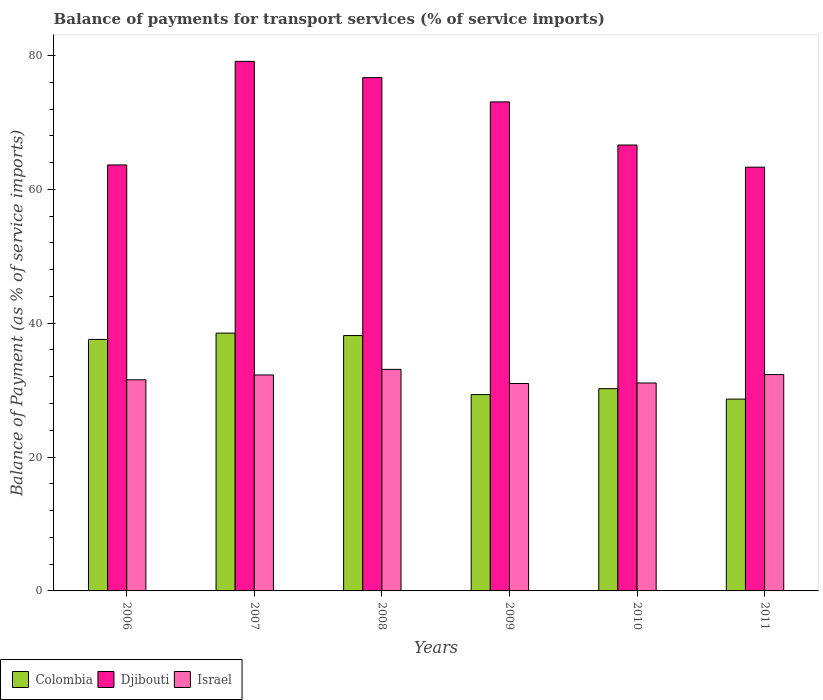How many different coloured bars are there?
Offer a terse response. 3. What is the balance of payments for transport services in Djibouti in 2006?
Offer a terse response. 63.64. Across all years, what is the maximum balance of payments for transport services in Djibouti?
Offer a terse response. 79.12. Across all years, what is the minimum balance of payments for transport services in Djibouti?
Ensure brevity in your answer.  63.31. In which year was the balance of payments for transport services in Djibouti minimum?
Offer a terse response. 2011. What is the total balance of payments for transport services in Colombia in the graph?
Offer a terse response. 202.45. What is the difference between the balance of payments for transport services in Colombia in 2009 and that in 2011?
Give a very brief answer. 0.67. What is the difference between the balance of payments for transport services in Colombia in 2008 and the balance of payments for transport services in Djibouti in 2006?
Ensure brevity in your answer.  -25.49. What is the average balance of payments for transport services in Israel per year?
Provide a succinct answer. 31.88. In the year 2010, what is the difference between the balance of payments for transport services in Colombia and balance of payments for transport services in Djibouti?
Make the answer very short. -36.4. In how many years, is the balance of payments for transport services in Djibouti greater than 24 %?
Make the answer very short. 6. What is the ratio of the balance of payments for transport services in Colombia in 2006 to that in 2010?
Offer a terse response. 1.24. Is the difference between the balance of payments for transport services in Colombia in 2009 and 2011 greater than the difference between the balance of payments for transport services in Djibouti in 2009 and 2011?
Make the answer very short. No. What is the difference between the highest and the second highest balance of payments for transport services in Israel?
Offer a terse response. 0.78. What is the difference between the highest and the lowest balance of payments for transport services in Djibouti?
Make the answer very short. 15.81. What does the 1st bar from the left in 2010 represents?
Make the answer very short. Colombia. Is it the case that in every year, the sum of the balance of payments for transport services in Djibouti and balance of payments for transport services in Colombia is greater than the balance of payments for transport services in Israel?
Offer a terse response. Yes. Are all the bars in the graph horizontal?
Offer a terse response. No. Where does the legend appear in the graph?
Ensure brevity in your answer.  Bottom left. How many legend labels are there?
Your response must be concise. 3. How are the legend labels stacked?
Ensure brevity in your answer.  Horizontal. What is the title of the graph?
Your answer should be compact. Balance of payments for transport services (% of service imports). Does "Arab World" appear as one of the legend labels in the graph?
Your answer should be very brief. No. What is the label or title of the X-axis?
Ensure brevity in your answer.  Years. What is the label or title of the Y-axis?
Keep it short and to the point. Balance of Payment (as % of service imports). What is the Balance of Payment (as % of service imports) in Colombia in 2006?
Ensure brevity in your answer.  37.57. What is the Balance of Payment (as % of service imports) of Djibouti in 2006?
Keep it short and to the point. 63.64. What is the Balance of Payment (as % of service imports) in Israel in 2006?
Make the answer very short. 31.55. What is the Balance of Payment (as % of service imports) in Colombia in 2007?
Ensure brevity in your answer.  38.52. What is the Balance of Payment (as % of service imports) of Djibouti in 2007?
Ensure brevity in your answer.  79.12. What is the Balance of Payment (as % of service imports) of Israel in 2007?
Offer a very short reply. 32.27. What is the Balance of Payment (as % of service imports) of Colombia in 2008?
Keep it short and to the point. 38.15. What is the Balance of Payment (as % of service imports) in Djibouti in 2008?
Keep it short and to the point. 76.69. What is the Balance of Payment (as % of service imports) in Israel in 2008?
Your answer should be compact. 33.1. What is the Balance of Payment (as % of service imports) in Colombia in 2009?
Your answer should be very brief. 29.33. What is the Balance of Payment (as % of service imports) in Djibouti in 2009?
Keep it short and to the point. 73.06. What is the Balance of Payment (as % of service imports) of Israel in 2009?
Ensure brevity in your answer.  30.99. What is the Balance of Payment (as % of service imports) in Colombia in 2010?
Keep it short and to the point. 30.22. What is the Balance of Payment (as % of service imports) in Djibouti in 2010?
Offer a very short reply. 66.62. What is the Balance of Payment (as % of service imports) in Israel in 2010?
Your response must be concise. 31.07. What is the Balance of Payment (as % of service imports) of Colombia in 2011?
Your answer should be compact. 28.66. What is the Balance of Payment (as % of service imports) in Djibouti in 2011?
Offer a very short reply. 63.31. What is the Balance of Payment (as % of service imports) in Israel in 2011?
Offer a terse response. 32.32. Across all years, what is the maximum Balance of Payment (as % of service imports) of Colombia?
Ensure brevity in your answer.  38.52. Across all years, what is the maximum Balance of Payment (as % of service imports) in Djibouti?
Offer a very short reply. 79.12. Across all years, what is the maximum Balance of Payment (as % of service imports) in Israel?
Give a very brief answer. 33.1. Across all years, what is the minimum Balance of Payment (as % of service imports) of Colombia?
Offer a terse response. 28.66. Across all years, what is the minimum Balance of Payment (as % of service imports) in Djibouti?
Your answer should be very brief. 63.31. Across all years, what is the minimum Balance of Payment (as % of service imports) of Israel?
Offer a terse response. 30.99. What is the total Balance of Payment (as % of service imports) of Colombia in the graph?
Offer a very short reply. 202.45. What is the total Balance of Payment (as % of service imports) of Djibouti in the graph?
Offer a very short reply. 422.45. What is the total Balance of Payment (as % of service imports) of Israel in the graph?
Your answer should be compact. 191.29. What is the difference between the Balance of Payment (as % of service imports) of Colombia in 2006 and that in 2007?
Your answer should be compact. -0.95. What is the difference between the Balance of Payment (as % of service imports) of Djibouti in 2006 and that in 2007?
Your response must be concise. -15.48. What is the difference between the Balance of Payment (as % of service imports) in Israel in 2006 and that in 2007?
Ensure brevity in your answer.  -0.72. What is the difference between the Balance of Payment (as % of service imports) in Colombia in 2006 and that in 2008?
Provide a succinct answer. -0.58. What is the difference between the Balance of Payment (as % of service imports) in Djibouti in 2006 and that in 2008?
Offer a very short reply. -13.05. What is the difference between the Balance of Payment (as % of service imports) in Israel in 2006 and that in 2008?
Provide a succinct answer. -1.56. What is the difference between the Balance of Payment (as % of service imports) of Colombia in 2006 and that in 2009?
Offer a very short reply. 8.25. What is the difference between the Balance of Payment (as % of service imports) of Djibouti in 2006 and that in 2009?
Keep it short and to the point. -9.42. What is the difference between the Balance of Payment (as % of service imports) of Israel in 2006 and that in 2009?
Offer a terse response. 0.55. What is the difference between the Balance of Payment (as % of service imports) in Colombia in 2006 and that in 2010?
Make the answer very short. 7.36. What is the difference between the Balance of Payment (as % of service imports) of Djibouti in 2006 and that in 2010?
Provide a succinct answer. -2.98. What is the difference between the Balance of Payment (as % of service imports) of Israel in 2006 and that in 2010?
Your response must be concise. 0.48. What is the difference between the Balance of Payment (as % of service imports) in Colombia in 2006 and that in 2011?
Keep it short and to the point. 8.92. What is the difference between the Balance of Payment (as % of service imports) in Djibouti in 2006 and that in 2011?
Your answer should be compact. 0.33. What is the difference between the Balance of Payment (as % of service imports) in Israel in 2006 and that in 2011?
Your answer should be compact. -0.78. What is the difference between the Balance of Payment (as % of service imports) of Colombia in 2007 and that in 2008?
Your answer should be compact. 0.37. What is the difference between the Balance of Payment (as % of service imports) of Djibouti in 2007 and that in 2008?
Your answer should be very brief. 2.43. What is the difference between the Balance of Payment (as % of service imports) of Colombia in 2007 and that in 2009?
Offer a very short reply. 9.19. What is the difference between the Balance of Payment (as % of service imports) of Djibouti in 2007 and that in 2009?
Your answer should be compact. 6.06. What is the difference between the Balance of Payment (as % of service imports) in Israel in 2007 and that in 2009?
Offer a terse response. 1.28. What is the difference between the Balance of Payment (as % of service imports) in Colombia in 2007 and that in 2010?
Ensure brevity in your answer.  8.3. What is the difference between the Balance of Payment (as % of service imports) in Djibouti in 2007 and that in 2010?
Ensure brevity in your answer.  12.5. What is the difference between the Balance of Payment (as % of service imports) in Israel in 2007 and that in 2010?
Provide a succinct answer. 1.2. What is the difference between the Balance of Payment (as % of service imports) of Colombia in 2007 and that in 2011?
Offer a very short reply. 9.86. What is the difference between the Balance of Payment (as % of service imports) in Djibouti in 2007 and that in 2011?
Provide a succinct answer. 15.81. What is the difference between the Balance of Payment (as % of service imports) of Israel in 2007 and that in 2011?
Your answer should be very brief. -0.05. What is the difference between the Balance of Payment (as % of service imports) in Colombia in 2008 and that in 2009?
Provide a short and direct response. 8.83. What is the difference between the Balance of Payment (as % of service imports) in Djibouti in 2008 and that in 2009?
Ensure brevity in your answer.  3.63. What is the difference between the Balance of Payment (as % of service imports) of Israel in 2008 and that in 2009?
Give a very brief answer. 2.11. What is the difference between the Balance of Payment (as % of service imports) of Colombia in 2008 and that in 2010?
Provide a succinct answer. 7.94. What is the difference between the Balance of Payment (as % of service imports) in Djibouti in 2008 and that in 2010?
Provide a succinct answer. 10.07. What is the difference between the Balance of Payment (as % of service imports) in Israel in 2008 and that in 2010?
Offer a terse response. 2.04. What is the difference between the Balance of Payment (as % of service imports) of Colombia in 2008 and that in 2011?
Your response must be concise. 9.5. What is the difference between the Balance of Payment (as % of service imports) of Djibouti in 2008 and that in 2011?
Ensure brevity in your answer.  13.38. What is the difference between the Balance of Payment (as % of service imports) in Israel in 2008 and that in 2011?
Give a very brief answer. 0.78. What is the difference between the Balance of Payment (as % of service imports) in Colombia in 2009 and that in 2010?
Your response must be concise. -0.89. What is the difference between the Balance of Payment (as % of service imports) in Djibouti in 2009 and that in 2010?
Ensure brevity in your answer.  6.44. What is the difference between the Balance of Payment (as % of service imports) in Israel in 2009 and that in 2010?
Your answer should be very brief. -0.08. What is the difference between the Balance of Payment (as % of service imports) of Colombia in 2009 and that in 2011?
Ensure brevity in your answer.  0.67. What is the difference between the Balance of Payment (as % of service imports) of Djibouti in 2009 and that in 2011?
Keep it short and to the point. 9.75. What is the difference between the Balance of Payment (as % of service imports) of Israel in 2009 and that in 2011?
Provide a short and direct response. -1.33. What is the difference between the Balance of Payment (as % of service imports) in Colombia in 2010 and that in 2011?
Give a very brief answer. 1.56. What is the difference between the Balance of Payment (as % of service imports) in Djibouti in 2010 and that in 2011?
Your answer should be very brief. 3.31. What is the difference between the Balance of Payment (as % of service imports) in Israel in 2010 and that in 2011?
Give a very brief answer. -1.25. What is the difference between the Balance of Payment (as % of service imports) of Colombia in 2006 and the Balance of Payment (as % of service imports) of Djibouti in 2007?
Your answer should be very brief. -41.55. What is the difference between the Balance of Payment (as % of service imports) in Colombia in 2006 and the Balance of Payment (as % of service imports) in Israel in 2007?
Offer a terse response. 5.31. What is the difference between the Balance of Payment (as % of service imports) of Djibouti in 2006 and the Balance of Payment (as % of service imports) of Israel in 2007?
Make the answer very short. 31.38. What is the difference between the Balance of Payment (as % of service imports) in Colombia in 2006 and the Balance of Payment (as % of service imports) in Djibouti in 2008?
Give a very brief answer. -39.12. What is the difference between the Balance of Payment (as % of service imports) in Colombia in 2006 and the Balance of Payment (as % of service imports) in Israel in 2008?
Your answer should be compact. 4.47. What is the difference between the Balance of Payment (as % of service imports) of Djibouti in 2006 and the Balance of Payment (as % of service imports) of Israel in 2008?
Your answer should be compact. 30.54. What is the difference between the Balance of Payment (as % of service imports) of Colombia in 2006 and the Balance of Payment (as % of service imports) of Djibouti in 2009?
Make the answer very short. -35.49. What is the difference between the Balance of Payment (as % of service imports) in Colombia in 2006 and the Balance of Payment (as % of service imports) in Israel in 2009?
Provide a short and direct response. 6.58. What is the difference between the Balance of Payment (as % of service imports) of Djibouti in 2006 and the Balance of Payment (as % of service imports) of Israel in 2009?
Offer a terse response. 32.65. What is the difference between the Balance of Payment (as % of service imports) of Colombia in 2006 and the Balance of Payment (as % of service imports) of Djibouti in 2010?
Ensure brevity in your answer.  -29.04. What is the difference between the Balance of Payment (as % of service imports) in Colombia in 2006 and the Balance of Payment (as % of service imports) in Israel in 2010?
Your answer should be compact. 6.51. What is the difference between the Balance of Payment (as % of service imports) in Djibouti in 2006 and the Balance of Payment (as % of service imports) in Israel in 2010?
Provide a short and direct response. 32.58. What is the difference between the Balance of Payment (as % of service imports) of Colombia in 2006 and the Balance of Payment (as % of service imports) of Djibouti in 2011?
Ensure brevity in your answer.  -25.74. What is the difference between the Balance of Payment (as % of service imports) of Colombia in 2006 and the Balance of Payment (as % of service imports) of Israel in 2011?
Offer a very short reply. 5.25. What is the difference between the Balance of Payment (as % of service imports) in Djibouti in 2006 and the Balance of Payment (as % of service imports) in Israel in 2011?
Make the answer very short. 31.32. What is the difference between the Balance of Payment (as % of service imports) in Colombia in 2007 and the Balance of Payment (as % of service imports) in Djibouti in 2008?
Give a very brief answer. -38.17. What is the difference between the Balance of Payment (as % of service imports) of Colombia in 2007 and the Balance of Payment (as % of service imports) of Israel in 2008?
Ensure brevity in your answer.  5.42. What is the difference between the Balance of Payment (as % of service imports) in Djibouti in 2007 and the Balance of Payment (as % of service imports) in Israel in 2008?
Offer a very short reply. 46.02. What is the difference between the Balance of Payment (as % of service imports) in Colombia in 2007 and the Balance of Payment (as % of service imports) in Djibouti in 2009?
Your response must be concise. -34.54. What is the difference between the Balance of Payment (as % of service imports) of Colombia in 2007 and the Balance of Payment (as % of service imports) of Israel in 2009?
Your response must be concise. 7.53. What is the difference between the Balance of Payment (as % of service imports) of Djibouti in 2007 and the Balance of Payment (as % of service imports) of Israel in 2009?
Provide a succinct answer. 48.13. What is the difference between the Balance of Payment (as % of service imports) of Colombia in 2007 and the Balance of Payment (as % of service imports) of Djibouti in 2010?
Keep it short and to the point. -28.1. What is the difference between the Balance of Payment (as % of service imports) in Colombia in 2007 and the Balance of Payment (as % of service imports) in Israel in 2010?
Provide a succinct answer. 7.45. What is the difference between the Balance of Payment (as % of service imports) of Djibouti in 2007 and the Balance of Payment (as % of service imports) of Israel in 2010?
Offer a terse response. 48.05. What is the difference between the Balance of Payment (as % of service imports) of Colombia in 2007 and the Balance of Payment (as % of service imports) of Djibouti in 2011?
Give a very brief answer. -24.79. What is the difference between the Balance of Payment (as % of service imports) in Colombia in 2007 and the Balance of Payment (as % of service imports) in Israel in 2011?
Provide a succinct answer. 6.2. What is the difference between the Balance of Payment (as % of service imports) in Djibouti in 2007 and the Balance of Payment (as % of service imports) in Israel in 2011?
Make the answer very short. 46.8. What is the difference between the Balance of Payment (as % of service imports) of Colombia in 2008 and the Balance of Payment (as % of service imports) of Djibouti in 2009?
Your answer should be compact. -34.91. What is the difference between the Balance of Payment (as % of service imports) of Colombia in 2008 and the Balance of Payment (as % of service imports) of Israel in 2009?
Ensure brevity in your answer.  7.16. What is the difference between the Balance of Payment (as % of service imports) in Djibouti in 2008 and the Balance of Payment (as % of service imports) in Israel in 2009?
Ensure brevity in your answer.  45.7. What is the difference between the Balance of Payment (as % of service imports) in Colombia in 2008 and the Balance of Payment (as % of service imports) in Djibouti in 2010?
Your answer should be very brief. -28.46. What is the difference between the Balance of Payment (as % of service imports) in Colombia in 2008 and the Balance of Payment (as % of service imports) in Israel in 2010?
Offer a very short reply. 7.09. What is the difference between the Balance of Payment (as % of service imports) in Djibouti in 2008 and the Balance of Payment (as % of service imports) in Israel in 2010?
Offer a very short reply. 45.63. What is the difference between the Balance of Payment (as % of service imports) in Colombia in 2008 and the Balance of Payment (as % of service imports) in Djibouti in 2011?
Provide a succinct answer. -25.16. What is the difference between the Balance of Payment (as % of service imports) in Colombia in 2008 and the Balance of Payment (as % of service imports) in Israel in 2011?
Give a very brief answer. 5.83. What is the difference between the Balance of Payment (as % of service imports) of Djibouti in 2008 and the Balance of Payment (as % of service imports) of Israel in 2011?
Keep it short and to the point. 44.37. What is the difference between the Balance of Payment (as % of service imports) of Colombia in 2009 and the Balance of Payment (as % of service imports) of Djibouti in 2010?
Keep it short and to the point. -37.29. What is the difference between the Balance of Payment (as % of service imports) in Colombia in 2009 and the Balance of Payment (as % of service imports) in Israel in 2010?
Make the answer very short. -1.74. What is the difference between the Balance of Payment (as % of service imports) in Djibouti in 2009 and the Balance of Payment (as % of service imports) in Israel in 2010?
Provide a short and direct response. 42. What is the difference between the Balance of Payment (as % of service imports) of Colombia in 2009 and the Balance of Payment (as % of service imports) of Djibouti in 2011?
Make the answer very short. -33.98. What is the difference between the Balance of Payment (as % of service imports) in Colombia in 2009 and the Balance of Payment (as % of service imports) in Israel in 2011?
Your answer should be very brief. -2.99. What is the difference between the Balance of Payment (as % of service imports) of Djibouti in 2009 and the Balance of Payment (as % of service imports) of Israel in 2011?
Your answer should be very brief. 40.74. What is the difference between the Balance of Payment (as % of service imports) of Colombia in 2010 and the Balance of Payment (as % of service imports) of Djibouti in 2011?
Offer a terse response. -33.1. What is the difference between the Balance of Payment (as % of service imports) in Colombia in 2010 and the Balance of Payment (as % of service imports) in Israel in 2011?
Provide a short and direct response. -2.11. What is the difference between the Balance of Payment (as % of service imports) of Djibouti in 2010 and the Balance of Payment (as % of service imports) of Israel in 2011?
Your answer should be compact. 34.3. What is the average Balance of Payment (as % of service imports) of Colombia per year?
Ensure brevity in your answer.  33.74. What is the average Balance of Payment (as % of service imports) in Djibouti per year?
Your response must be concise. 70.41. What is the average Balance of Payment (as % of service imports) in Israel per year?
Ensure brevity in your answer.  31.88. In the year 2006, what is the difference between the Balance of Payment (as % of service imports) in Colombia and Balance of Payment (as % of service imports) in Djibouti?
Offer a very short reply. -26.07. In the year 2006, what is the difference between the Balance of Payment (as % of service imports) of Colombia and Balance of Payment (as % of service imports) of Israel?
Keep it short and to the point. 6.03. In the year 2006, what is the difference between the Balance of Payment (as % of service imports) of Djibouti and Balance of Payment (as % of service imports) of Israel?
Your answer should be compact. 32.1. In the year 2007, what is the difference between the Balance of Payment (as % of service imports) of Colombia and Balance of Payment (as % of service imports) of Djibouti?
Your answer should be compact. -40.6. In the year 2007, what is the difference between the Balance of Payment (as % of service imports) in Colombia and Balance of Payment (as % of service imports) in Israel?
Your answer should be very brief. 6.25. In the year 2007, what is the difference between the Balance of Payment (as % of service imports) in Djibouti and Balance of Payment (as % of service imports) in Israel?
Your answer should be compact. 46.85. In the year 2008, what is the difference between the Balance of Payment (as % of service imports) in Colombia and Balance of Payment (as % of service imports) in Djibouti?
Provide a succinct answer. -38.54. In the year 2008, what is the difference between the Balance of Payment (as % of service imports) in Colombia and Balance of Payment (as % of service imports) in Israel?
Your response must be concise. 5.05. In the year 2008, what is the difference between the Balance of Payment (as % of service imports) of Djibouti and Balance of Payment (as % of service imports) of Israel?
Your answer should be very brief. 43.59. In the year 2009, what is the difference between the Balance of Payment (as % of service imports) of Colombia and Balance of Payment (as % of service imports) of Djibouti?
Your answer should be compact. -43.73. In the year 2009, what is the difference between the Balance of Payment (as % of service imports) in Colombia and Balance of Payment (as % of service imports) in Israel?
Provide a succinct answer. -1.66. In the year 2009, what is the difference between the Balance of Payment (as % of service imports) in Djibouti and Balance of Payment (as % of service imports) in Israel?
Offer a terse response. 42.07. In the year 2010, what is the difference between the Balance of Payment (as % of service imports) in Colombia and Balance of Payment (as % of service imports) in Djibouti?
Offer a very short reply. -36.4. In the year 2010, what is the difference between the Balance of Payment (as % of service imports) in Colombia and Balance of Payment (as % of service imports) in Israel?
Provide a succinct answer. -0.85. In the year 2010, what is the difference between the Balance of Payment (as % of service imports) in Djibouti and Balance of Payment (as % of service imports) in Israel?
Provide a succinct answer. 35.55. In the year 2011, what is the difference between the Balance of Payment (as % of service imports) of Colombia and Balance of Payment (as % of service imports) of Djibouti?
Your answer should be very brief. -34.66. In the year 2011, what is the difference between the Balance of Payment (as % of service imports) of Colombia and Balance of Payment (as % of service imports) of Israel?
Your response must be concise. -3.67. In the year 2011, what is the difference between the Balance of Payment (as % of service imports) of Djibouti and Balance of Payment (as % of service imports) of Israel?
Offer a terse response. 30.99. What is the ratio of the Balance of Payment (as % of service imports) of Colombia in 2006 to that in 2007?
Ensure brevity in your answer.  0.98. What is the ratio of the Balance of Payment (as % of service imports) of Djibouti in 2006 to that in 2007?
Your answer should be very brief. 0.8. What is the ratio of the Balance of Payment (as % of service imports) in Israel in 2006 to that in 2007?
Provide a succinct answer. 0.98. What is the ratio of the Balance of Payment (as % of service imports) in Colombia in 2006 to that in 2008?
Your answer should be very brief. 0.98. What is the ratio of the Balance of Payment (as % of service imports) of Djibouti in 2006 to that in 2008?
Make the answer very short. 0.83. What is the ratio of the Balance of Payment (as % of service imports) of Israel in 2006 to that in 2008?
Offer a terse response. 0.95. What is the ratio of the Balance of Payment (as % of service imports) of Colombia in 2006 to that in 2009?
Offer a very short reply. 1.28. What is the ratio of the Balance of Payment (as % of service imports) of Djibouti in 2006 to that in 2009?
Ensure brevity in your answer.  0.87. What is the ratio of the Balance of Payment (as % of service imports) in Israel in 2006 to that in 2009?
Make the answer very short. 1.02. What is the ratio of the Balance of Payment (as % of service imports) in Colombia in 2006 to that in 2010?
Offer a very short reply. 1.24. What is the ratio of the Balance of Payment (as % of service imports) in Djibouti in 2006 to that in 2010?
Your answer should be very brief. 0.96. What is the ratio of the Balance of Payment (as % of service imports) in Israel in 2006 to that in 2010?
Your answer should be very brief. 1.02. What is the ratio of the Balance of Payment (as % of service imports) of Colombia in 2006 to that in 2011?
Provide a short and direct response. 1.31. What is the ratio of the Balance of Payment (as % of service imports) in Djibouti in 2006 to that in 2011?
Offer a terse response. 1.01. What is the ratio of the Balance of Payment (as % of service imports) in Colombia in 2007 to that in 2008?
Ensure brevity in your answer.  1.01. What is the ratio of the Balance of Payment (as % of service imports) in Djibouti in 2007 to that in 2008?
Keep it short and to the point. 1.03. What is the ratio of the Balance of Payment (as % of service imports) of Israel in 2007 to that in 2008?
Offer a terse response. 0.97. What is the ratio of the Balance of Payment (as % of service imports) of Colombia in 2007 to that in 2009?
Make the answer very short. 1.31. What is the ratio of the Balance of Payment (as % of service imports) of Djibouti in 2007 to that in 2009?
Give a very brief answer. 1.08. What is the ratio of the Balance of Payment (as % of service imports) in Israel in 2007 to that in 2009?
Give a very brief answer. 1.04. What is the ratio of the Balance of Payment (as % of service imports) of Colombia in 2007 to that in 2010?
Offer a very short reply. 1.27. What is the ratio of the Balance of Payment (as % of service imports) of Djibouti in 2007 to that in 2010?
Give a very brief answer. 1.19. What is the ratio of the Balance of Payment (as % of service imports) in Israel in 2007 to that in 2010?
Make the answer very short. 1.04. What is the ratio of the Balance of Payment (as % of service imports) of Colombia in 2007 to that in 2011?
Give a very brief answer. 1.34. What is the ratio of the Balance of Payment (as % of service imports) of Djibouti in 2007 to that in 2011?
Ensure brevity in your answer.  1.25. What is the ratio of the Balance of Payment (as % of service imports) of Colombia in 2008 to that in 2009?
Offer a terse response. 1.3. What is the ratio of the Balance of Payment (as % of service imports) in Djibouti in 2008 to that in 2009?
Ensure brevity in your answer.  1.05. What is the ratio of the Balance of Payment (as % of service imports) of Israel in 2008 to that in 2009?
Your response must be concise. 1.07. What is the ratio of the Balance of Payment (as % of service imports) in Colombia in 2008 to that in 2010?
Ensure brevity in your answer.  1.26. What is the ratio of the Balance of Payment (as % of service imports) of Djibouti in 2008 to that in 2010?
Give a very brief answer. 1.15. What is the ratio of the Balance of Payment (as % of service imports) in Israel in 2008 to that in 2010?
Your response must be concise. 1.07. What is the ratio of the Balance of Payment (as % of service imports) of Colombia in 2008 to that in 2011?
Ensure brevity in your answer.  1.33. What is the ratio of the Balance of Payment (as % of service imports) in Djibouti in 2008 to that in 2011?
Your answer should be very brief. 1.21. What is the ratio of the Balance of Payment (as % of service imports) of Israel in 2008 to that in 2011?
Your answer should be very brief. 1.02. What is the ratio of the Balance of Payment (as % of service imports) of Colombia in 2009 to that in 2010?
Your response must be concise. 0.97. What is the ratio of the Balance of Payment (as % of service imports) in Djibouti in 2009 to that in 2010?
Make the answer very short. 1.1. What is the ratio of the Balance of Payment (as % of service imports) of Colombia in 2009 to that in 2011?
Ensure brevity in your answer.  1.02. What is the ratio of the Balance of Payment (as % of service imports) of Djibouti in 2009 to that in 2011?
Offer a terse response. 1.15. What is the ratio of the Balance of Payment (as % of service imports) of Israel in 2009 to that in 2011?
Provide a short and direct response. 0.96. What is the ratio of the Balance of Payment (as % of service imports) in Colombia in 2010 to that in 2011?
Provide a succinct answer. 1.05. What is the ratio of the Balance of Payment (as % of service imports) in Djibouti in 2010 to that in 2011?
Provide a short and direct response. 1.05. What is the ratio of the Balance of Payment (as % of service imports) of Israel in 2010 to that in 2011?
Give a very brief answer. 0.96. What is the difference between the highest and the second highest Balance of Payment (as % of service imports) in Colombia?
Make the answer very short. 0.37. What is the difference between the highest and the second highest Balance of Payment (as % of service imports) in Djibouti?
Provide a short and direct response. 2.43. What is the difference between the highest and the second highest Balance of Payment (as % of service imports) in Israel?
Your answer should be very brief. 0.78. What is the difference between the highest and the lowest Balance of Payment (as % of service imports) in Colombia?
Provide a short and direct response. 9.86. What is the difference between the highest and the lowest Balance of Payment (as % of service imports) of Djibouti?
Your answer should be compact. 15.81. What is the difference between the highest and the lowest Balance of Payment (as % of service imports) in Israel?
Your answer should be very brief. 2.11. 